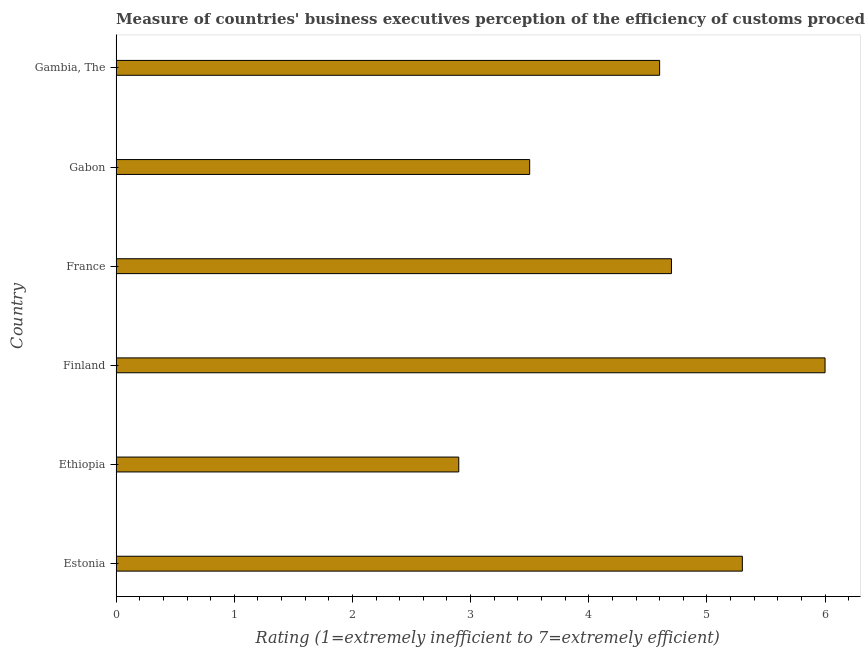Does the graph contain grids?
Offer a terse response. No. What is the title of the graph?
Your answer should be very brief. Measure of countries' business executives perception of the efficiency of customs procedures in 2014. What is the label or title of the X-axis?
Keep it short and to the point. Rating (1=extremely inefficient to 7=extremely efficient). What is the label or title of the Y-axis?
Offer a terse response. Country. Across all countries, what is the minimum rating measuring burden of customs procedure?
Make the answer very short. 2.9. In which country was the rating measuring burden of customs procedure minimum?
Ensure brevity in your answer.  Ethiopia. What is the sum of the rating measuring burden of customs procedure?
Provide a short and direct response. 27. What is the difference between the rating measuring burden of customs procedure in Ethiopia and Gabon?
Offer a very short reply. -0.6. What is the median rating measuring burden of customs procedure?
Your answer should be compact. 4.65. In how many countries, is the rating measuring burden of customs procedure greater than 0.6 ?
Offer a very short reply. 6. What is the ratio of the rating measuring burden of customs procedure in Ethiopia to that in Finland?
Keep it short and to the point. 0.48. Is the sum of the rating measuring burden of customs procedure in France and Gabon greater than the maximum rating measuring burden of customs procedure across all countries?
Make the answer very short. Yes. How many bars are there?
Ensure brevity in your answer.  6. How many countries are there in the graph?
Make the answer very short. 6. What is the difference between two consecutive major ticks on the X-axis?
Your response must be concise. 1. Are the values on the major ticks of X-axis written in scientific E-notation?
Keep it short and to the point. No. What is the Rating (1=extremely inefficient to 7=extremely efficient) of Estonia?
Offer a terse response. 5.3. What is the Rating (1=extremely inefficient to 7=extremely efficient) in Ethiopia?
Your answer should be compact. 2.9. What is the Rating (1=extremely inefficient to 7=extremely efficient) in Finland?
Provide a succinct answer. 6. What is the Rating (1=extremely inefficient to 7=extremely efficient) of France?
Your response must be concise. 4.7. What is the difference between the Rating (1=extremely inefficient to 7=extremely efficient) in Estonia and Ethiopia?
Ensure brevity in your answer.  2.4. What is the difference between the Rating (1=extremely inefficient to 7=extremely efficient) in Estonia and Finland?
Your response must be concise. -0.7. What is the difference between the Rating (1=extremely inefficient to 7=extremely efficient) in Estonia and France?
Provide a succinct answer. 0.6. What is the difference between the Rating (1=extremely inefficient to 7=extremely efficient) in Ethiopia and Finland?
Keep it short and to the point. -3.1. What is the difference between the Rating (1=extremely inefficient to 7=extremely efficient) in Ethiopia and Gabon?
Provide a succinct answer. -0.6. What is the difference between the Rating (1=extremely inefficient to 7=extremely efficient) in Ethiopia and Gambia, The?
Make the answer very short. -1.7. What is the difference between the Rating (1=extremely inefficient to 7=extremely efficient) in Finland and Gabon?
Offer a very short reply. 2.5. What is the difference between the Rating (1=extremely inefficient to 7=extremely efficient) in France and Gambia, The?
Offer a very short reply. 0.1. What is the difference between the Rating (1=extremely inefficient to 7=extremely efficient) in Gabon and Gambia, The?
Your response must be concise. -1.1. What is the ratio of the Rating (1=extremely inefficient to 7=extremely efficient) in Estonia to that in Ethiopia?
Provide a succinct answer. 1.83. What is the ratio of the Rating (1=extremely inefficient to 7=extremely efficient) in Estonia to that in Finland?
Your response must be concise. 0.88. What is the ratio of the Rating (1=extremely inefficient to 7=extremely efficient) in Estonia to that in France?
Ensure brevity in your answer.  1.13. What is the ratio of the Rating (1=extremely inefficient to 7=extremely efficient) in Estonia to that in Gabon?
Provide a short and direct response. 1.51. What is the ratio of the Rating (1=extremely inefficient to 7=extremely efficient) in Estonia to that in Gambia, The?
Your answer should be very brief. 1.15. What is the ratio of the Rating (1=extremely inefficient to 7=extremely efficient) in Ethiopia to that in Finland?
Ensure brevity in your answer.  0.48. What is the ratio of the Rating (1=extremely inefficient to 7=extremely efficient) in Ethiopia to that in France?
Your response must be concise. 0.62. What is the ratio of the Rating (1=extremely inefficient to 7=extremely efficient) in Ethiopia to that in Gabon?
Your response must be concise. 0.83. What is the ratio of the Rating (1=extremely inefficient to 7=extremely efficient) in Ethiopia to that in Gambia, The?
Offer a very short reply. 0.63. What is the ratio of the Rating (1=extremely inefficient to 7=extremely efficient) in Finland to that in France?
Provide a short and direct response. 1.28. What is the ratio of the Rating (1=extremely inefficient to 7=extremely efficient) in Finland to that in Gabon?
Keep it short and to the point. 1.71. What is the ratio of the Rating (1=extremely inefficient to 7=extremely efficient) in Finland to that in Gambia, The?
Your answer should be very brief. 1.3. What is the ratio of the Rating (1=extremely inefficient to 7=extremely efficient) in France to that in Gabon?
Provide a short and direct response. 1.34. What is the ratio of the Rating (1=extremely inefficient to 7=extremely efficient) in France to that in Gambia, The?
Offer a terse response. 1.02. What is the ratio of the Rating (1=extremely inefficient to 7=extremely efficient) in Gabon to that in Gambia, The?
Your answer should be very brief. 0.76. 